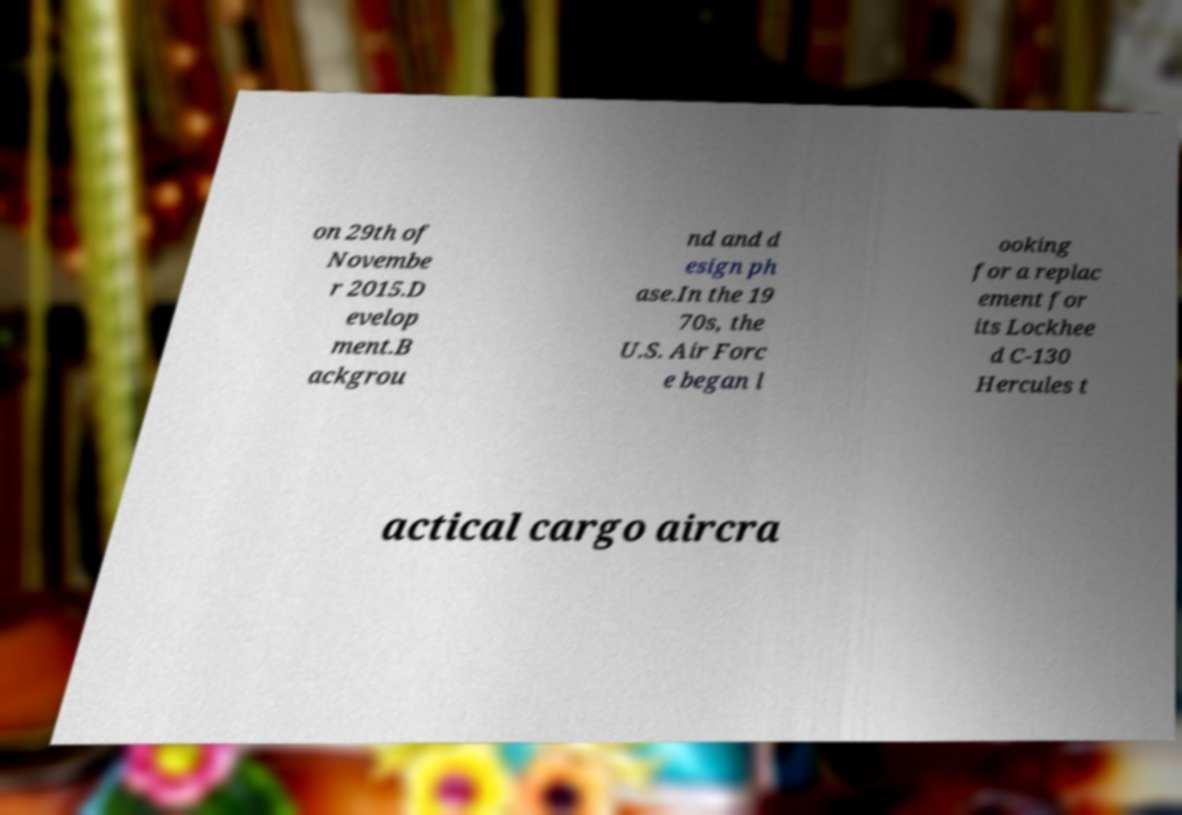Can you read and provide the text displayed in the image?This photo seems to have some interesting text. Can you extract and type it out for me? on 29th of Novembe r 2015.D evelop ment.B ackgrou nd and d esign ph ase.In the 19 70s, the U.S. Air Forc e began l ooking for a replac ement for its Lockhee d C-130 Hercules t actical cargo aircra 